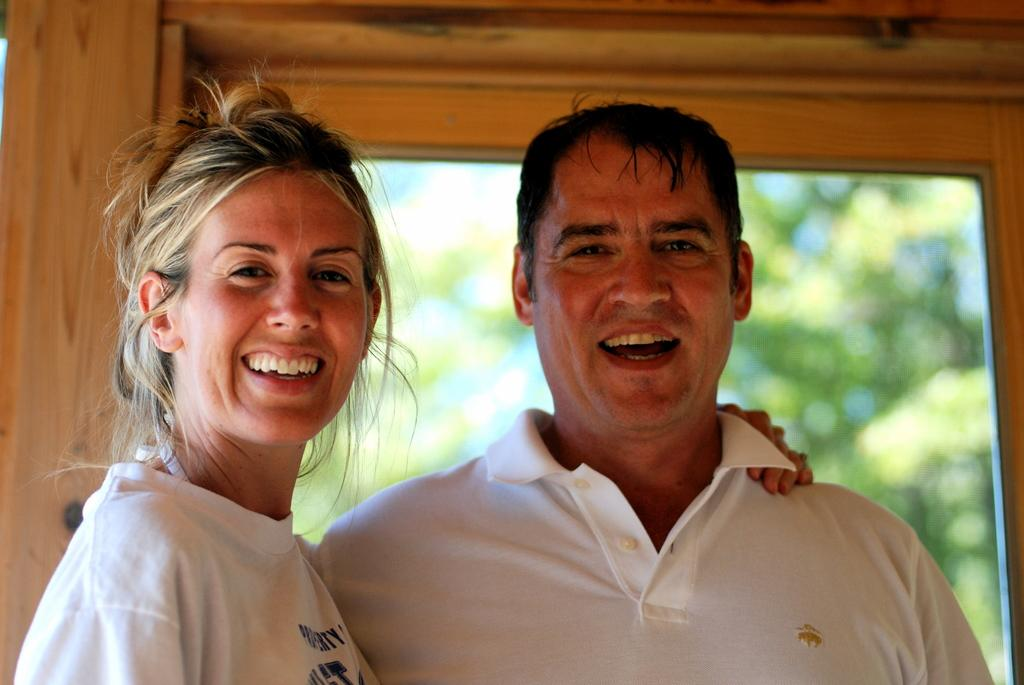What is the man in the image wearing? The man is wearing a white T-shirt. What is the woman in the image wearing? The woman is also wearing a white T-shirt. What are the man and woman doing in the image? The man and woman are standing. What can be seen in the background of the image? There are trees in the background of the image. What type of feast is being prepared in the image? There is no indication of a feast or any food preparation in the image. Can you describe the pickle that the man is holding in the image? There is no pickle present in the image. 